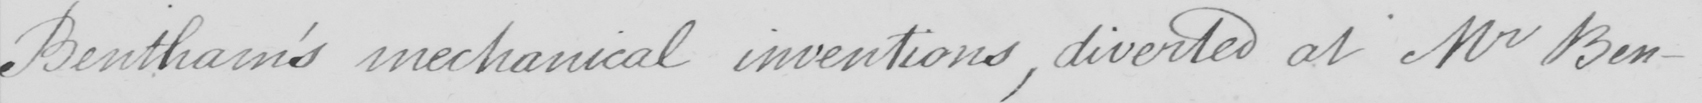Transcribe the text shown in this historical manuscript line. Bentham ' s mechanical inventions , diverted at Mr Ben- 